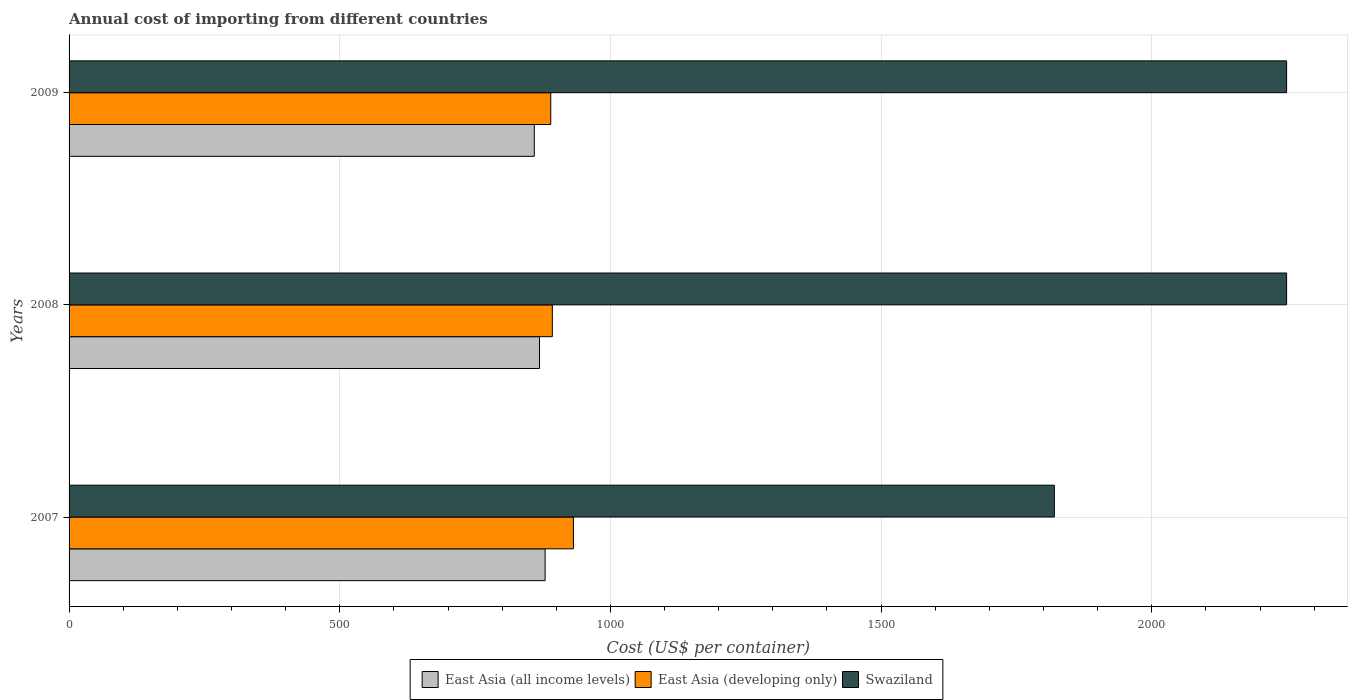How many different coloured bars are there?
Keep it short and to the point. 3. Are the number of bars on each tick of the Y-axis equal?
Provide a short and direct response. Yes. How many bars are there on the 3rd tick from the top?
Keep it short and to the point. 3. What is the label of the 2nd group of bars from the top?
Make the answer very short. 2008. What is the total annual cost of importing in Swaziland in 2007?
Provide a succinct answer. 1820. Across all years, what is the maximum total annual cost of importing in East Asia (all income levels)?
Your answer should be compact. 879.32. Across all years, what is the minimum total annual cost of importing in East Asia (all income levels)?
Make the answer very short. 859.36. What is the total total annual cost of importing in Swaziland in the graph?
Ensure brevity in your answer.  6318. What is the difference between the total annual cost of importing in East Asia (all income levels) in 2007 and that in 2009?
Keep it short and to the point. 19.96. What is the difference between the total annual cost of importing in Swaziland in 2009 and the total annual cost of importing in East Asia (all income levels) in 2007?
Provide a succinct answer. 1369.68. What is the average total annual cost of importing in East Asia (all income levels) per year?
Offer a very short reply. 869.23. In the year 2007, what is the difference between the total annual cost of importing in East Asia (all income levels) and total annual cost of importing in East Asia (developing only)?
Ensure brevity in your answer.  -52.33. In how many years, is the total annual cost of importing in East Asia (all income levels) greater than 400 US$?
Your response must be concise. 3. What is the ratio of the total annual cost of importing in Swaziland in 2008 to that in 2009?
Offer a very short reply. 1. Is the total annual cost of importing in Swaziland in 2007 less than that in 2009?
Provide a succinct answer. Yes. Is the difference between the total annual cost of importing in East Asia (all income levels) in 2007 and 2008 greater than the difference between the total annual cost of importing in East Asia (developing only) in 2007 and 2008?
Make the answer very short. No. What is the difference between the highest and the lowest total annual cost of importing in East Asia (developing only)?
Ensure brevity in your answer.  41.9. What does the 2nd bar from the top in 2007 represents?
Your answer should be compact. East Asia (developing only). What does the 1st bar from the bottom in 2008 represents?
Your response must be concise. East Asia (all income levels). How many bars are there?
Offer a very short reply. 9. How many years are there in the graph?
Your response must be concise. 3. Does the graph contain any zero values?
Offer a very short reply. No. Does the graph contain grids?
Your answer should be compact. Yes. Where does the legend appear in the graph?
Give a very brief answer. Bottom center. How many legend labels are there?
Offer a very short reply. 3. How are the legend labels stacked?
Provide a succinct answer. Horizontal. What is the title of the graph?
Your answer should be compact. Annual cost of importing from different countries. What is the label or title of the X-axis?
Offer a terse response. Cost (US$ per container). What is the Cost (US$ per container) in East Asia (all income levels) in 2007?
Offer a terse response. 879.32. What is the Cost (US$ per container) of East Asia (developing only) in 2007?
Keep it short and to the point. 931.65. What is the Cost (US$ per container) of Swaziland in 2007?
Give a very brief answer. 1820. What is the Cost (US$ per container) of East Asia (all income levels) in 2008?
Offer a terse response. 869. What is the Cost (US$ per container) of East Asia (developing only) in 2008?
Your response must be concise. 892.65. What is the Cost (US$ per container) of Swaziland in 2008?
Your answer should be compact. 2249. What is the Cost (US$ per container) of East Asia (all income levels) in 2009?
Your answer should be very brief. 859.36. What is the Cost (US$ per container) of East Asia (developing only) in 2009?
Make the answer very short. 889.75. What is the Cost (US$ per container) of Swaziland in 2009?
Provide a short and direct response. 2249. Across all years, what is the maximum Cost (US$ per container) of East Asia (all income levels)?
Provide a short and direct response. 879.32. Across all years, what is the maximum Cost (US$ per container) in East Asia (developing only)?
Offer a terse response. 931.65. Across all years, what is the maximum Cost (US$ per container) in Swaziland?
Offer a very short reply. 2249. Across all years, what is the minimum Cost (US$ per container) in East Asia (all income levels)?
Provide a succinct answer. 859.36. Across all years, what is the minimum Cost (US$ per container) in East Asia (developing only)?
Your answer should be very brief. 889.75. Across all years, what is the minimum Cost (US$ per container) of Swaziland?
Ensure brevity in your answer.  1820. What is the total Cost (US$ per container) in East Asia (all income levels) in the graph?
Give a very brief answer. 2607.68. What is the total Cost (US$ per container) in East Asia (developing only) in the graph?
Provide a succinct answer. 2714.05. What is the total Cost (US$ per container) of Swaziland in the graph?
Give a very brief answer. 6318. What is the difference between the Cost (US$ per container) of East Asia (all income levels) in 2007 and that in 2008?
Ensure brevity in your answer.  10.32. What is the difference between the Cost (US$ per container) in Swaziland in 2007 and that in 2008?
Your answer should be compact. -429. What is the difference between the Cost (US$ per container) of East Asia (all income levels) in 2007 and that in 2009?
Keep it short and to the point. 19.96. What is the difference between the Cost (US$ per container) of East Asia (developing only) in 2007 and that in 2009?
Provide a succinct answer. 41.9. What is the difference between the Cost (US$ per container) in Swaziland in 2007 and that in 2009?
Offer a very short reply. -429. What is the difference between the Cost (US$ per container) in East Asia (all income levels) in 2008 and that in 2009?
Ensure brevity in your answer.  9.64. What is the difference between the Cost (US$ per container) of East Asia (all income levels) in 2007 and the Cost (US$ per container) of East Asia (developing only) in 2008?
Make the answer very short. -13.33. What is the difference between the Cost (US$ per container) in East Asia (all income levels) in 2007 and the Cost (US$ per container) in Swaziland in 2008?
Your response must be concise. -1369.68. What is the difference between the Cost (US$ per container) of East Asia (developing only) in 2007 and the Cost (US$ per container) of Swaziland in 2008?
Provide a succinct answer. -1317.35. What is the difference between the Cost (US$ per container) in East Asia (all income levels) in 2007 and the Cost (US$ per container) in East Asia (developing only) in 2009?
Offer a terse response. -10.43. What is the difference between the Cost (US$ per container) of East Asia (all income levels) in 2007 and the Cost (US$ per container) of Swaziland in 2009?
Your response must be concise. -1369.68. What is the difference between the Cost (US$ per container) of East Asia (developing only) in 2007 and the Cost (US$ per container) of Swaziland in 2009?
Provide a succinct answer. -1317.35. What is the difference between the Cost (US$ per container) of East Asia (all income levels) in 2008 and the Cost (US$ per container) of East Asia (developing only) in 2009?
Offer a very short reply. -20.75. What is the difference between the Cost (US$ per container) of East Asia (all income levels) in 2008 and the Cost (US$ per container) of Swaziland in 2009?
Your answer should be compact. -1380. What is the difference between the Cost (US$ per container) of East Asia (developing only) in 2008 and the Cost (US$ per container) of Swaziland in 2009?
Keep it short and to the point. -1356.35. What is the average Cost (US$ per container) in East Asia (all income levels) per year?
Your answer should be compact. 869.23. What is the average Cost (US$ per container) in East Asia (developing only) per year?
Your answer should be compact. 904.68. What is the average Cost (US$ per container) of Swaziland per year?
Give a very brief answer. 2106. In the year 2007, what is the difference between the Cost (US$ per container) in East Asia (all income levels) and Cost (US$ per container) in East Asia (developing only)?
Make the answer very short. -52.33. In the year 2007, what is the difference between the Cost (US$ per container) of East Asia (all income levels) and Cost (US$ per container) of Swaziland?
Your answer should be compact. -940.68. In the year 2007, what is the difference between the Cost (US$ per container) of East Asia (developing only) and Cost (US$ per container) of Swaziland?
Ensure brevity in your answer.  -888.35. In the year 2008, what is the difference between the Cost (US$ per container) in East Asia (all income levels) and Cost (US$ per container) in East Asia (developing only)?
Ensure brevity in your answer.  -23.65. In the year 2008, what is the difference between the Cost (US$ per container) in East Asia (all income levels) and Cost (US$ per container) in Swaziland?
Make the answer very short. -1380. In the year 2008, what is the difference between the Cost (US$ per container) of East Asia (developing only) and Cost (US$ per container) of Swaziland?
Offer a very short reply. -1356.35. In the year 2009, what is the difference between the Cost (US$ per container) in East Asia (all income levels) and Cost (US$ per container) in East Asia (developing only)?
Offer a terse response. -30.39. In the year 2009, what is the difference between the Cost (US$ per container) of East Asia (all income levels) and Cost (US$ per container) of Swaziland?
Ensure brevity in your answer.  -1389.64. In the year 2009, what is the difference between the Cost (US$ per container) of East Asia (developing only) and Cost (US$ per container) of Swaziland?
Offer a terse response. -1359.25. What is the ratio of the Cost (US$ per container) in East Asia (all income levels) in 2007 to that in 2008?
Make the answer very short. 1.01. What is the ratio of the Cost (US$ per container) of East Asia (developing only) in 2007 to that in 2008?
Ensure brevity in your answer.  1.04. What is the ratio of the Cost (US$ per container) of Swaziland in 2007 to that in 2008?
Your answer should be very brief. 0.81. What is the ratio of the Cost (US$ per container) of East Asia (all income levels) in 2007 to that in 2009?
Keep it short and to the point. 1.02. What is the ratio of the Cost (US$ per container) in East Asia (developing only) in 2007 to that in 2009?
Offer a very short reply. 1.05. What is the ratio of the Cost (US$ per container) of Swaziland in 2007 to that in 2009?
Make the answer very short. 0.81. What is the ratio of the Cost (US$ per container) of East Asia (all income levels) in 2008 to that in 2009?
Make the answer very short. 1.01. What is the ratio of the Cost (US$ per container) in East Asia (developing only) in 2008 to that in 2009?
Ensure brevity in your answer.  1. What is the ratio of the Cost (US$ per container) of Swaziland in 2008 to that in 2009?
Offer a terse response. 1. What is the difference between the highest and the second highest Cost (US$ per container) of East Asia (all income levels)?
Provide a short and direct response. 10.32. What is the difference between the highest and the second highest Cost (US$ per container) in East Asia (developing only)?
Ensure brevity in your answer.  39. What is the difference between the highest and the second highest Cost (US$ per container) in Swaziland?
Your response must be concise. 0. What is the difference between the highest and the lowest Cost (US$ per container) of East Asia (all income levels)?
Offer a terse response. 19.96. What is the difference between the highest and the lowest Cost (US$ per container) of East Asia (developing only)?
Ensure brevity in your answer.  41.9. What is the difference between the highest and the lowest Cost (US$ per container) in Swaziland?
Provide a succinct answer. 429. 